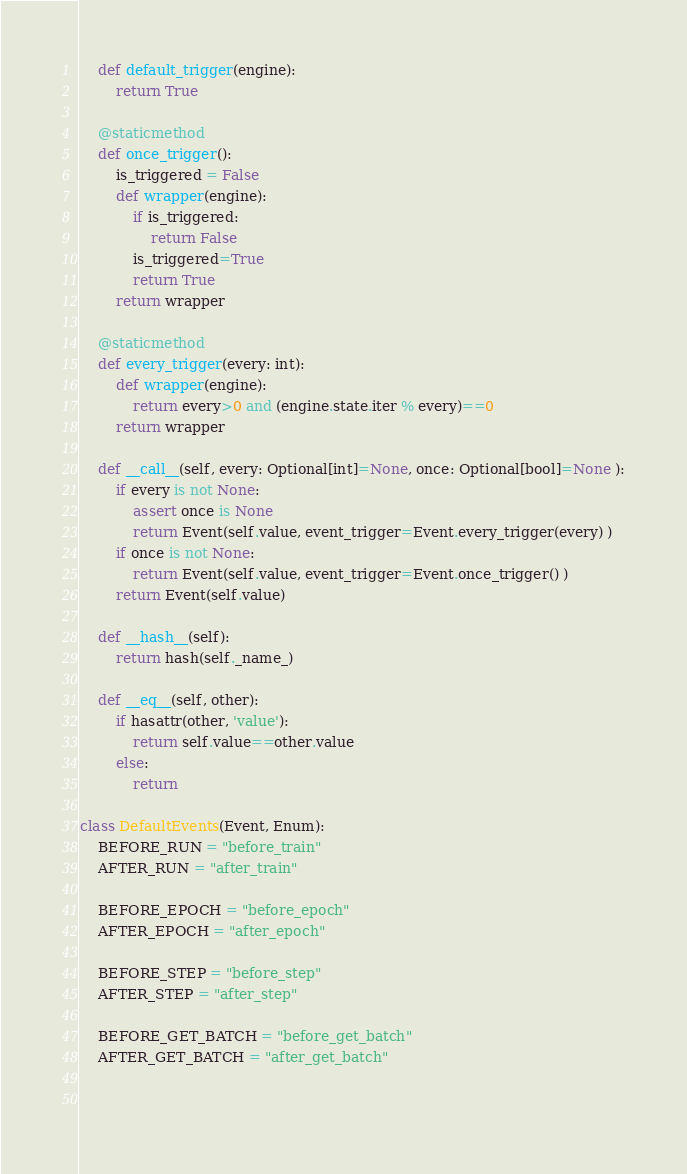Convert code to text. <code><loc_0><loc_0><loc_500><loc_500><_Python_>    def default_trigger(engine):
        return True

    @staticmethod
    def once_trigger():
        is_triggered = False
        def wrapper(engine):
            if is_triggered:
                return False
            is_triggered=True
            return True
        return wrapper

    @staticmethod
    def every_trigger(every: int):
        def wrapper(engine):
            return every>0 and (engine.state.iter % every)==0
        return wrapper

    def __call__(self, every: Optional[int]=None, once: Optional[bool]=None ):
        if every is not None:
            assert once is None
            return Event(self.value, event_trigger=Event.every_trigger(every) )
        if once is not None:
            return Event(self.value, event_trigger=Event.once_trigger() )
        return Event(self.value)

    def __hash__(self):
        return hash(self._name_)
    
    def __eq__(self, other):
        if hasattr(other, 'value'):
            return self.value==other.value
        else:
            return

class DefaultEvents(Event, Enum):
    BEFORE_RUN = "before_train"
    AFTER_RUN = "after_train"

    BEFORE_EPOCH = "before_epoch"
    AFTER_EPOCH = "after_epoch"

    BEFORE_STEP = "before_step"
    AFTER_STEP = "after_step"

    BEFORE_GET_BATCH = "before_get_batch"
    AFTER_GET_BATCH = "after_get_batch"

    </code> 